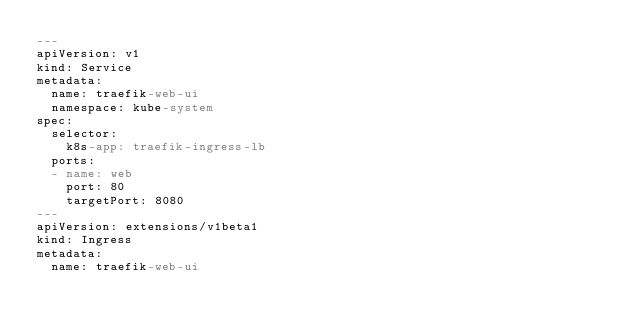<code> <loc_0><loc_0><loc_500><loc_500><_YAML_>---
apiVersion: v1
kind: Service
metadata:
  name: traefik-web-ui
  namespace: kube-system
spec:
  selector:
    k8s-app: traefik-ingress-lb
  ports:
  - name: web
    port: 80
    targetPort: 8080
---
apiVersion: extensions/v1beta1
kind: Ingress
metadata:
  name: traefik-web-ui</code> 